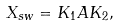Convert formula to latex. <formula><loc_0><loc_0><loc_500><loc_500>X _ { s w } = K _ { 1 } A K _ { 2 } ,</formula> 